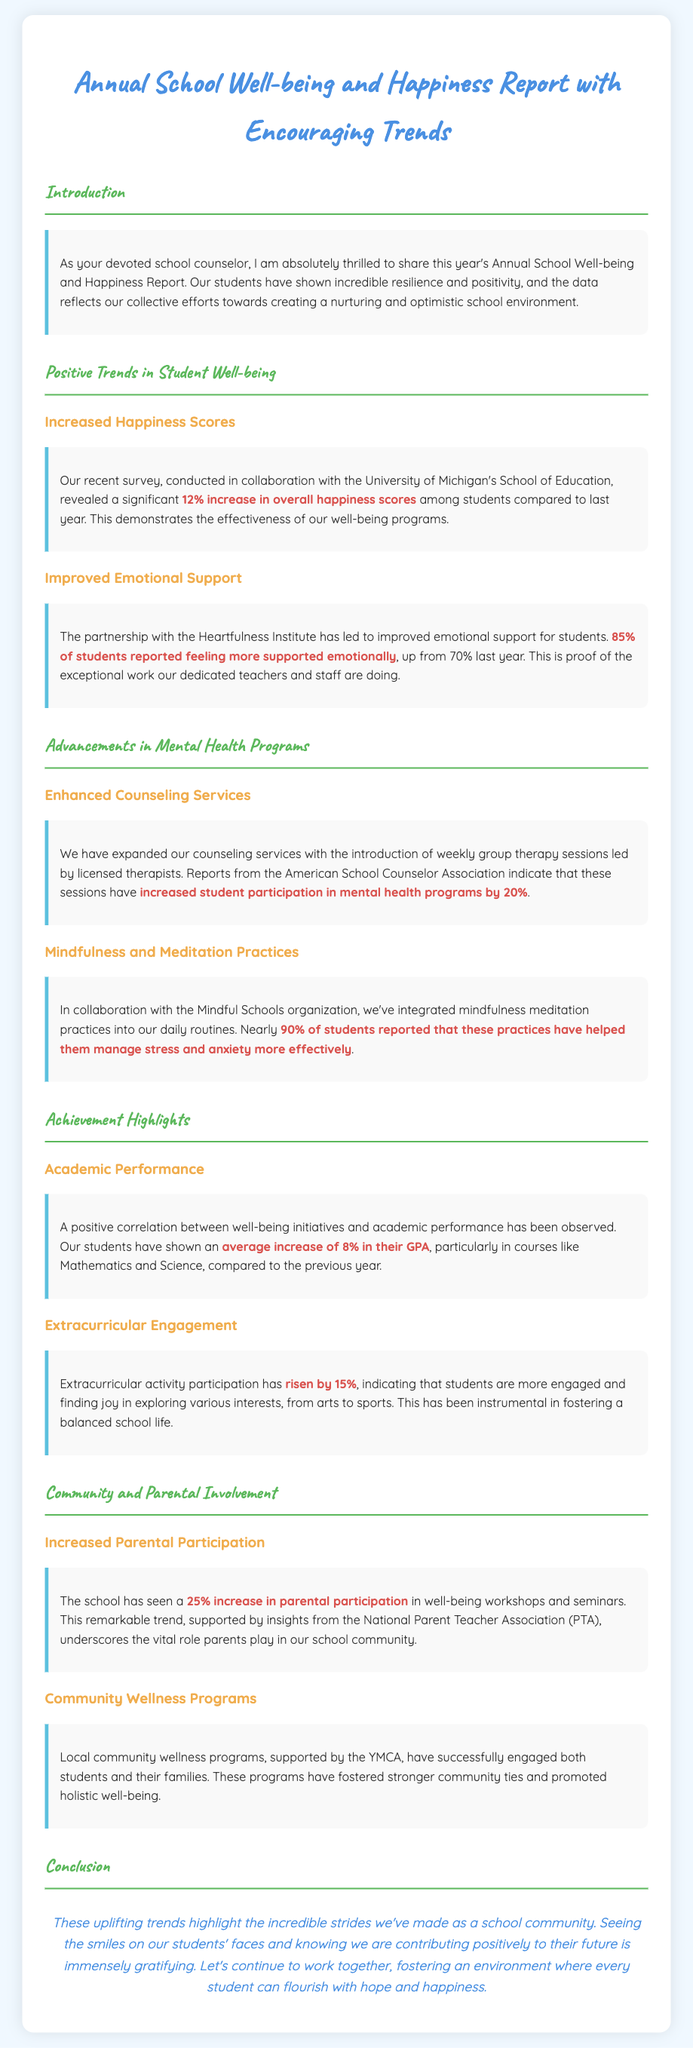What was the percentage increase in overall happiness scores? The document states there was a significant 12% increase in overall happiness scores among students.
Answer: 12% What percentage of students reported feeling more supported emotionally? According to the report, 85% of students reported feeling more supported emotionally, up from 70% last year.
Answer: 85% What is the increase in student participation in mental health programs? The report indicates that student participation in mental health programs has increased by 20%.
Answer: 20% How much did the GPA increase on average? The document mentions an average increase of 8% in GPA, particularly in Mathematics and Science.
Answer: 8% What is the percentage increase in parental participation in well-being workshops? The report highlights a 25% increase in parental participation in well-being workshops and seminars.
Answer: 25% What percentage of students reported mindfulness practices helping them manage stress? Nearly 90% of students reported that mindfulness practices helped them manage stress and anxiety more effectively.
Answer: 90% What organization is behind the collaboration for emotional support improvements? The Heartfulness Institute is credited for the improved emotional support for students.
Answer: Heartfulness Institute What is one impact of extracurricular activity participation as mentioned in the document? The report states that extracurricular activity participation has risen by 15%, indicating increased engagement among students.
Answer: 15% 